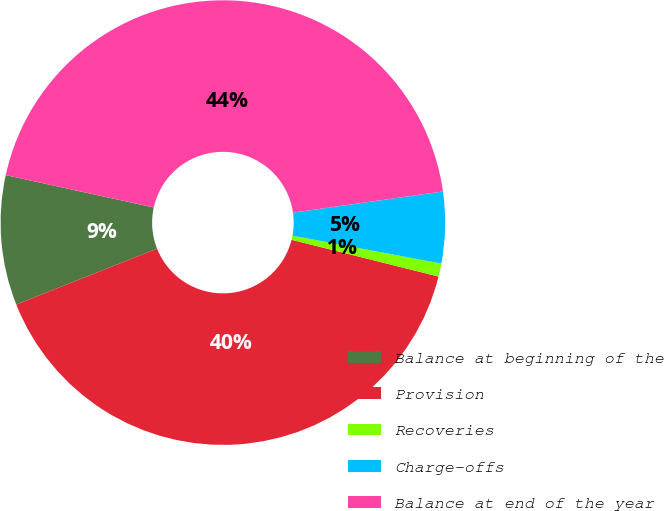<chart> <loc_0><loc_0><loc_500><loc_500><pie_chart><fcel>Balance at beginning of the<fcel>Provision<fcel>Recoveries<fcel>Charge-offs<fcel>Balance at end of the year<nl><fcel>9.43%<fcel>40.09%<fcel>0.95%<fcel>5.19%<fcel>44.33%<nl></chart> 